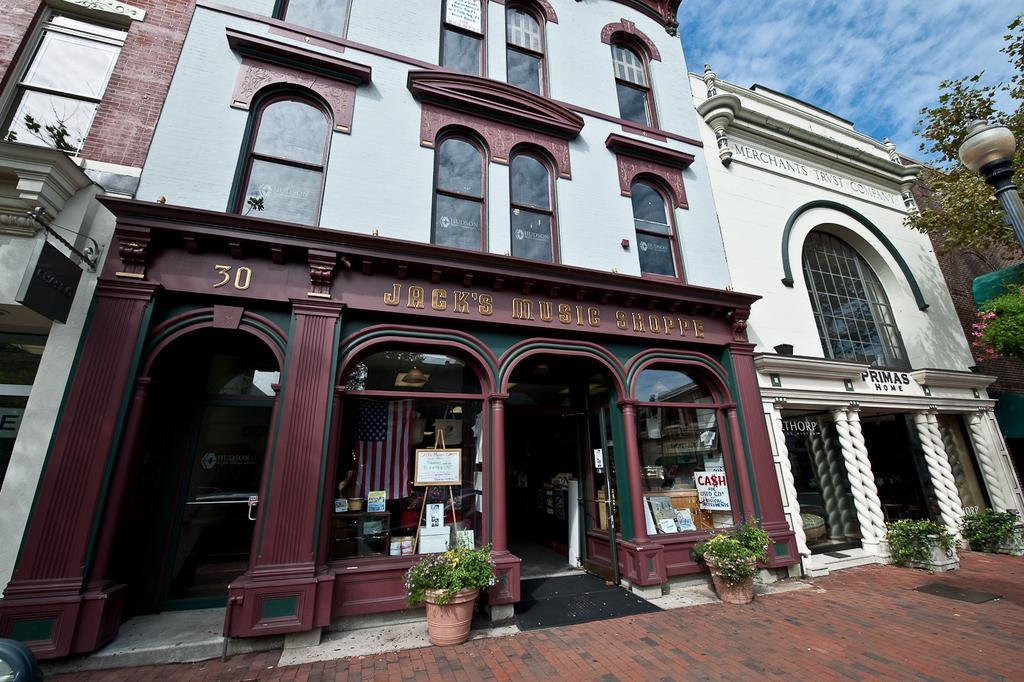In one or two sentences, can you explain what this image depicts? In this image in front there are buildings. In front of the buildings there are flower pots. On the right side of the image there are trees. There is a light. In the background of the image there is sky. 